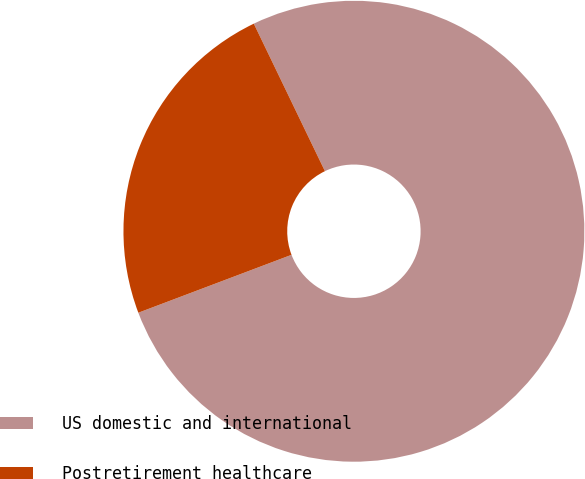Convert chart. <chart><loc_0><loc_0><loc_500><loc_500><pie_chart><fcel>US domestic and international<fcel>Postretirement healthcare<nl><fcel>76.4%<fcel>23.6%<nl></chart> 